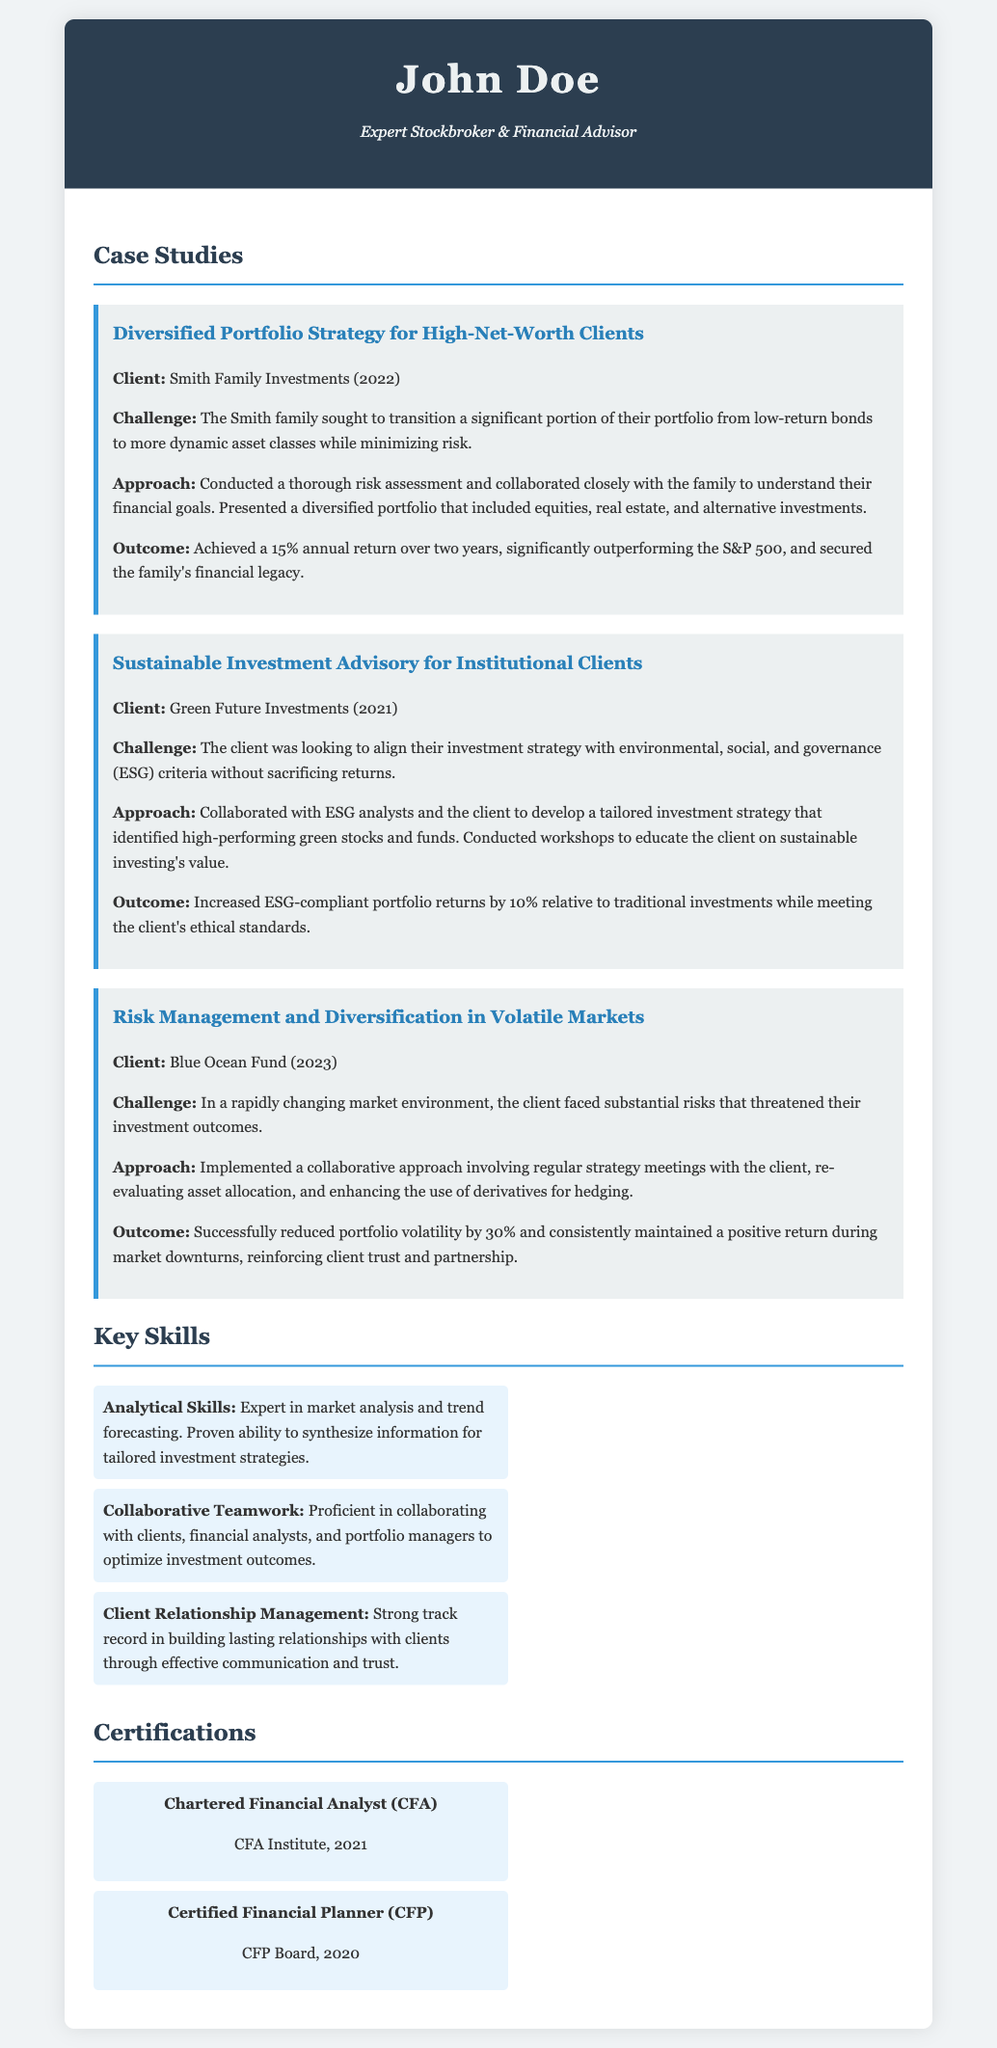What is the name of the first client mentioned? The first client mentioned is the Smith Family Investments, as stated in the case study section.
Answer: Smith Family Investments What was the annual return achieved for the Smith Family Investments? The document states that the annual return achieved was 15% over two years.
Answer: 15% Which year did the Sustainable Investment Advisory case study occur? The case study for Sustainable Investment Advisory took place in 2021, as indicated in the client section.
Answer: 2021 What was the challenge faced by Blue Ocean Fund? The document outlines that the challenge was substantial risks threatening investment outcomes.
Answer: Substantial risks What approach was taken in the case study involving the Green Future Investments? The approach involved collaborating with ESG analysts and developing a tailored investment strategy.
Answer: Collaborating with ESG analysts What was the outcome for the Blue Ocean Fund regarding portfolio volatility? The outcome achieved was a 30% reduction in portfolio volatility.
Answer: 30% Which certification was obtained in 2021? The document lists the Chartered Financial Analyst (CFA) certification as obtained in 2021.
Answer: Chartered Financial Analyst (CFA) What key skill relates to teamwork in the document? The collaborative teamwork skill is highlighted in the skills section.
Answer: Collaborative Teamwork What is the title of the document? The document is titled "Stockbroker CV," as found in the title tag.
Answer: Stockbroker CV 